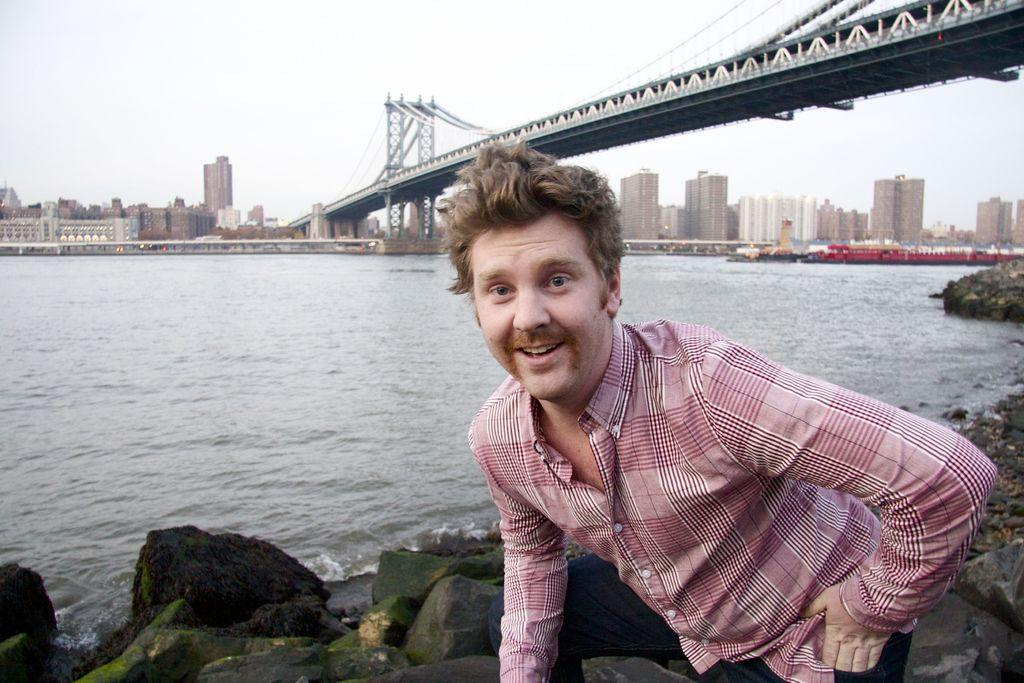Who is present in the image? There is a man in the image. What is the man doing in the image? The man is watching and smiling. What can be seen at the bottom of the image? There are rocks at the bottom of the image. What is visible in the background of the image? Water, a bridge, pillars, buildings, and the sky are visible in the background of the image. What disease is the man trying to cure in the image? There is no indication of a disease or any medical context in the image. The man is simply watching and smiling. 